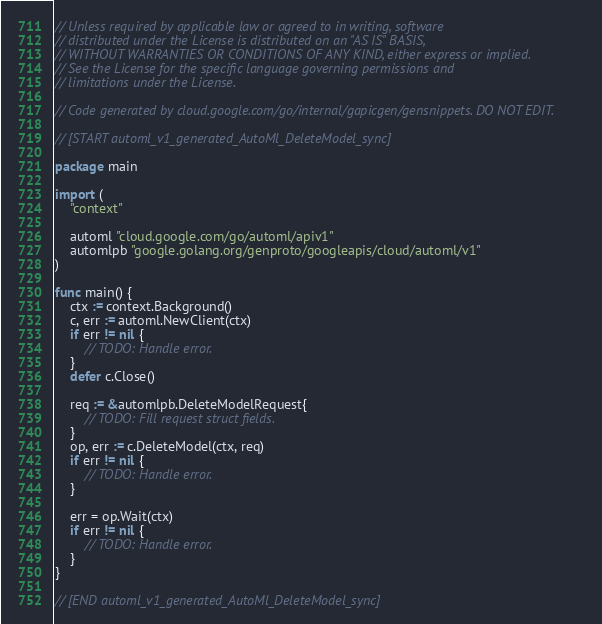Convert code to text. <code><loc_0><loc_0><loc_500><loc_500><_Go_>// Unless required by applicable law or agreed to in writing, software
// distributed under the License is distributed on an "AS IS" BASIS,
// WITHOUT WARRANTIES OR CONDITIONS OF ANY KIND, either express or implied.
// See the License for the specific language governing permissions and
// limitations under the License.

// Code generated by cloud.google.com/go/internal/gapicgen/gensnippets. DO NOT EDIT.

// [START automl_v1_generated_AutoMl_DeleteModel_sync]

package main

import (
	"context"

	automl "cloud.google.com/go/automl/apiv1"
	automlpb "google.golang.org/genproto/googleapis/cloud/automl/v1"
)

func main() {
	ctx := context.Background()
	c, err := automl.NewClient(ctx)
	if err != nil {
		// TODO: Handle error.
	}
	defer c.Close()

	req := &automlpb.DeleteModelRequest{
		// TODO: Fill request struct fields.
	}
	op, err := c.DeleteModel(ctx, req)
	if err != nil {
		// TODO: Handle error.
	}

	err = op.Wait(ctx)
	if err != nil {
		// TODO: Handle error.
	}
}

// [END automl_v1_generated_AutoMl_DeleteModel_sync]
</code> 